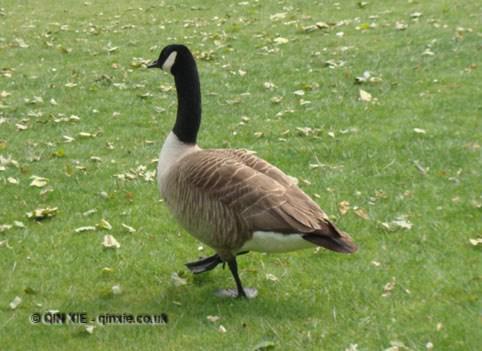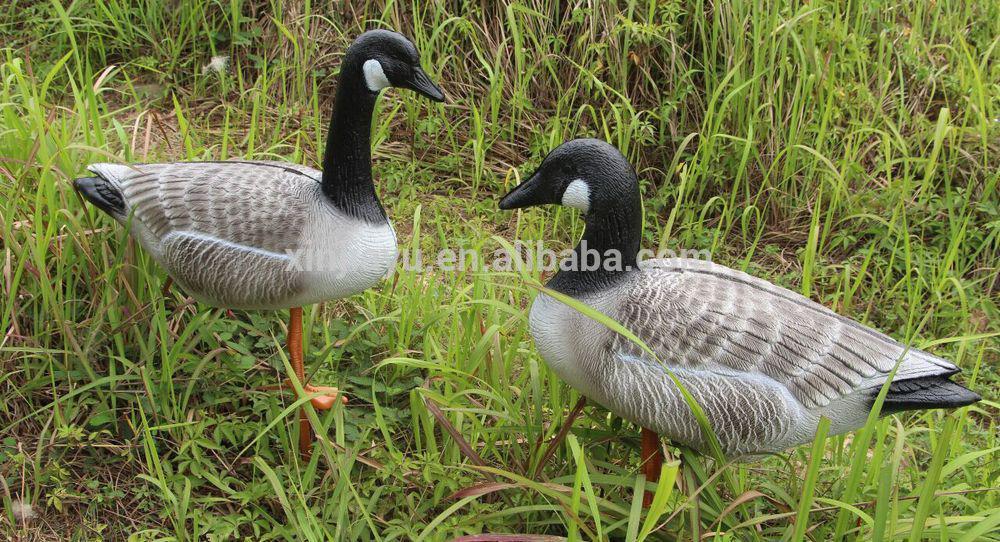The first image is the image on the left, the second image is the image on the right. Examine the images to the left and right. Is the description "The right image contains exactly one duck." accurate? Answer yes or no. No. The first image is the image on the left, the second image is the image on the right. For the images displayed, is the sentence "All geese have black necks, and one image contains at least twice as many geese as the other image." factually correct? Answer yes or no. Yes. 